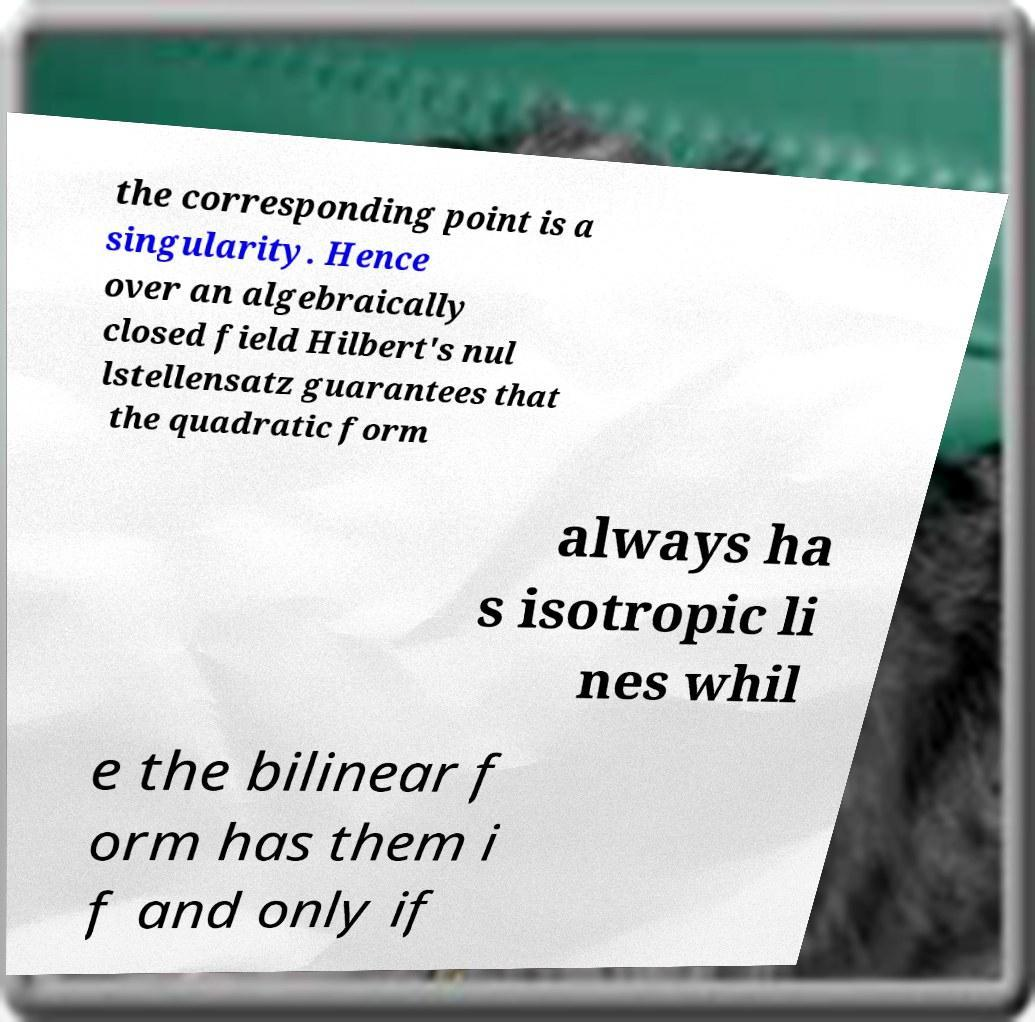For documentation purposes, I need the text within this image transcribed. Could you provide that? the corresponding point is a singularity. Hence over an algebraically closed field Hilbert's nul lstellensatz guarantees that the quadratic form always ha s isotropic li nes whil e the bilinear f orm has them i f and only if 